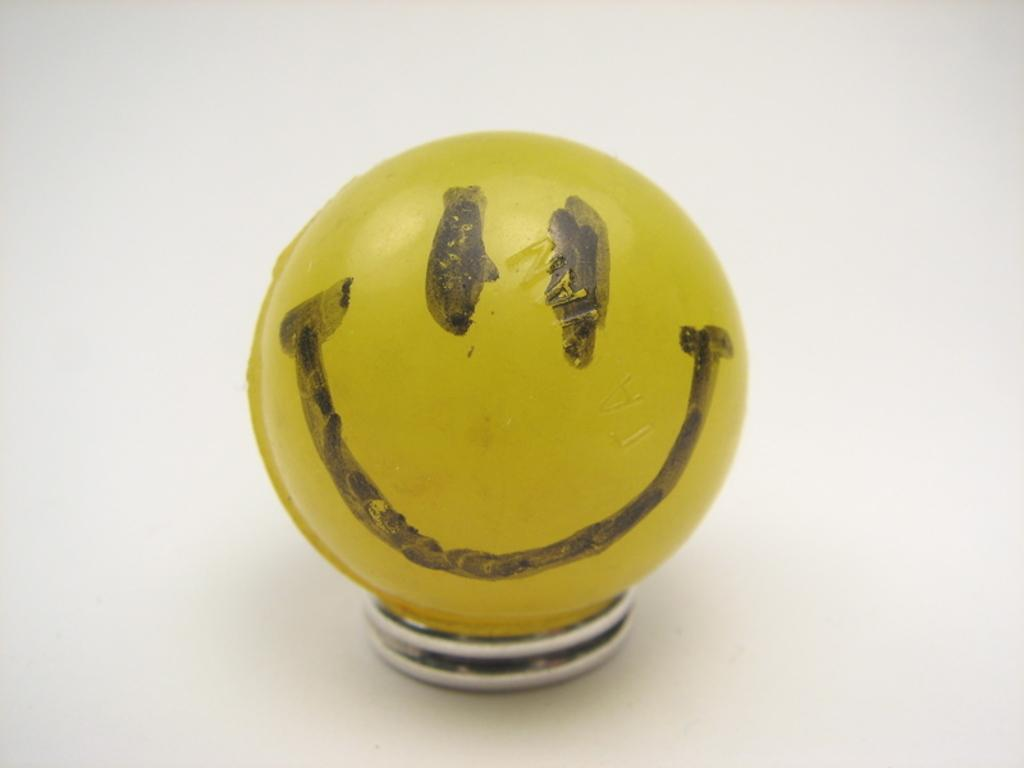What color is the ball in the image? The ball in the image is yellow. What is depicted on the ball? The ball has a smiley face symbol on it. What is the ball resting on in the image? The ball is on an object. Where is the object with the ball located? The object is on a platform. What is the reason for the fight between the two people in the image? There are no people present in the image, and therefore no fight can be observed. 